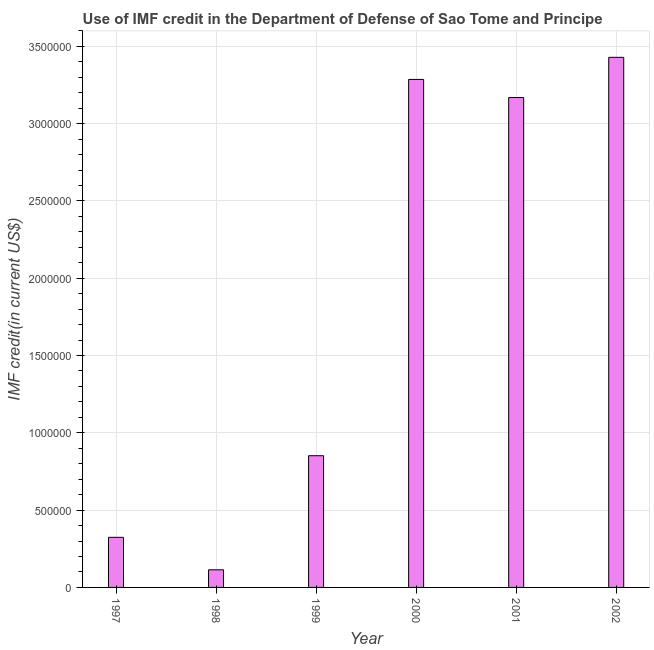What is the title of the graph?
Make the answer very short. Use of IMF credit in the Department of Defense of Sao Tome and Principe. What is the label or title of the X-axis?
Provide a short and direct response. Year. What is the label or title of the Y-axis?
Offer a very short reply. IMF credit(in current US$). What is the use of imf credit in dod in 2001?
Ensure brevity in your answer.  3.17e+06. Across all years, what is the maximum use of imf credit in dod?
Your answer should be compact. 3.43e+06. Across all years, what is the minimum use of imf credit in dod?
Provide a succinct answer. 1.14e+05. In which year was the use of imf credit in dod maximum?
Offer a very short reply. 2002. In which year was the use of imf credit in dod minimum?
Make the answer very short. 1998. What is the sum of the use of imf credit in dod?
Make the answer very short. 1.12e+07. What is the difference between the use of imf credit in dod in 1998 and 1999?
Provide a succinct answer. -7.38e+05. What is the average use of imf credit in dod per year?
Your response must be concise. 1.86e+06. What is the median use of imf credit in dod?
Make the answer very short. 2.01e+06. Do a majority of the years between 1998 and 1997 (inclusive) have use of imf credit in dod greater than 3000000 US$?
Your response must be concise. No. What is the ratio of the use of imf credit in dod in 1997 to that in 2000?
Provide a short and direct response. 0.1. Is the difference between the use of imf credit in dod in 1999 and 2000 greater than the difference between any two years?
Ensure brevity in your answer.  No. What is the difference between the highest and the second highest use of imf credit in dod?
Offer a terse response. 1.43e+05. Is the sum of the use of imf credit in dod in 2000 and 2002 greater than the maximum use of imf credit in dod across all years?
Keep it short and to the point. Yes. What is the difference between the highest and the lowest use of imf credit in dod?
Provide a short and direct response. 3.32e+06. How many years are there in the graph?
Provide a succinct answer. 6. What is the difference between two consecutive major ticks on the Y-axis?
Offer a terse response. 5.00e+05. What is the IMF credit(in current US$) in 1997?
Keep it short and to the point. 3.24e+05. What is the IMF credit(in current US$) of 1998?
Provide a succinct answer. 1.14e+05. What is the IMF credit(in current US$) of 1999?
Offer a very short reply. 8.52e+05. What is the IMF credit(in current US$) in 2000?
Your answer should be compact. 3.29e+06. What is the IMF credit(in current US$) in 2001?
Provide a short and direct response. 3.17e+06. What is the IMF credit(in current US$) of 2002?
Offer a very short reply. 3.43e+06. What is the difference between the IMF credit(in current US$) in 1997 and 1999?
Ensure brevity in your answer.  -5.28e+05. What is the difference between the IMF credit(in current US$) in 1997 and 2000?
Your answer should be compact. -2.96e+06. What is the difference between the IMF credit(in current US$) in 1997 and 2001?
Offer a terse response. -2.84e+06. What is the difference between the IMF credit(in current US$) in 1997 and 2002?
Offer a terse response. -3.10e+06. What is the difference between the IMF credit(in current US$) in 1998 and 1999?
Ensure brevity in your answer.  -7.38e+05. What is the difference between the IMF credit(in current US$) in 1998 and 2000?
Your answer should be compact. -3.17e+06. What is the difference between the IMF credit(in current US$) in 1998 and 2001?
Offer a terse response. -3.06e+06. What is the difference between the IMF credit(in current US$) in 1998 and 2002?
Keep it short and to the point. -3.32e+06. What is the difference between the IMF credit(in current US$) in 1999 and 2000?
Offer a very short reply. -2.43e+06. What is the difference between the IMF credit(in current US$) in 1999 and 2001?
Your response must be concise. -2.32e+06. What is the difference between the IMF credit(in current US$) in 1999 and 2002?
Offer a terse response. -2.58e+06. What is the difference between the IMF credit(in current US$) in 2000 and 2001?
Provide a succinct answer. 1.17e+05. What is the difference between the IMF credit(in current US$) in 2000 and 2002?
Offer a very short reply. -1.43e+05. What is the ratio of the IMF credit(in current US$) in 1997 to that in 1998?
Provide a short and direct response. 2.84. What is the ratio of the IMF credit(in current US$) in 1997 to that in 1999?
Provide a short and direct response. 0.38. What is the ratio of the IMF credit(in current US$) in 1997 to that in 2000?
Provide a short and direct response. 0.1. What is the ratio of the IMF credit(in current US$) in 1997 to that in 2001?
Offer a very short reply. 0.1. What is the ratio of the IMF credit(in current US$) in 1997 to that in 2002?
Keep it short and to the point. 0.09. What is the ratio of the IMF credit(in current US$) in 1998 to that in 1999?
Give a very brief answer. 0.13. What is the ratio of the IMF credit(in current US$) in 1998 to that in 2000?
Provide a succinct answer. 0.04. What is the ratio of the IMF credit(in current US$) in 1998 to that in 2001?
Offer a terse response. 0.04. What is the ratio of the IMF credit(in current US$) in 1998 to that in 2002?
Ensure brevity in your answer.  0.03. What is the ratio of the IMF credit(in current US$) in 1999 to that in 2000?
Keep it short and to the point. 0.26. What is the ratio of the IMF credit(in current US$) in 1999 to that in 2001?
Your answer should be compact. 0.27. What is the ratio of the IMF credit(in current US$) in 1999 to that in 2002?
Give a very brief answer. 0.25. What is the ratio of the IMF credit(in current US$) in 2000 to that in 2002?
Offer a terse response. 0.96. What is the ratio of the IMF credit(in current US$) in 2001 to that in 2002?
Make the answer very short. 0.92. 